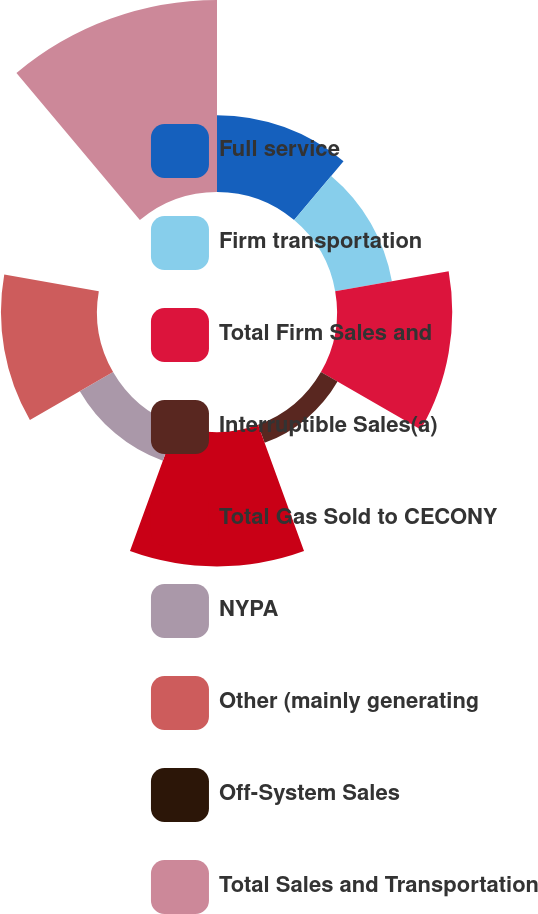<chart> <loc_0><loc_0><loc_500><loc_500><pie_chart><fcel>Full service<fcel>Firm transportation<fcel>Total Firm Sales and<fcel>Interruptible Sales(a)<fcel>Total Gas Sold to CECONY<fcel>NYPA<fcel>Other (mainly generating<fcel>Off-System Sales<fcel>Total Sales and Transportation<nl><fcel>10.53%<fcel>7.89%<fcel>15.79%<fcel>2.63%<fcel>18.42%<fcel>5.26%<fcel>13.16%<fcel>0.0%<fcel>26.31%<nl></chart> 